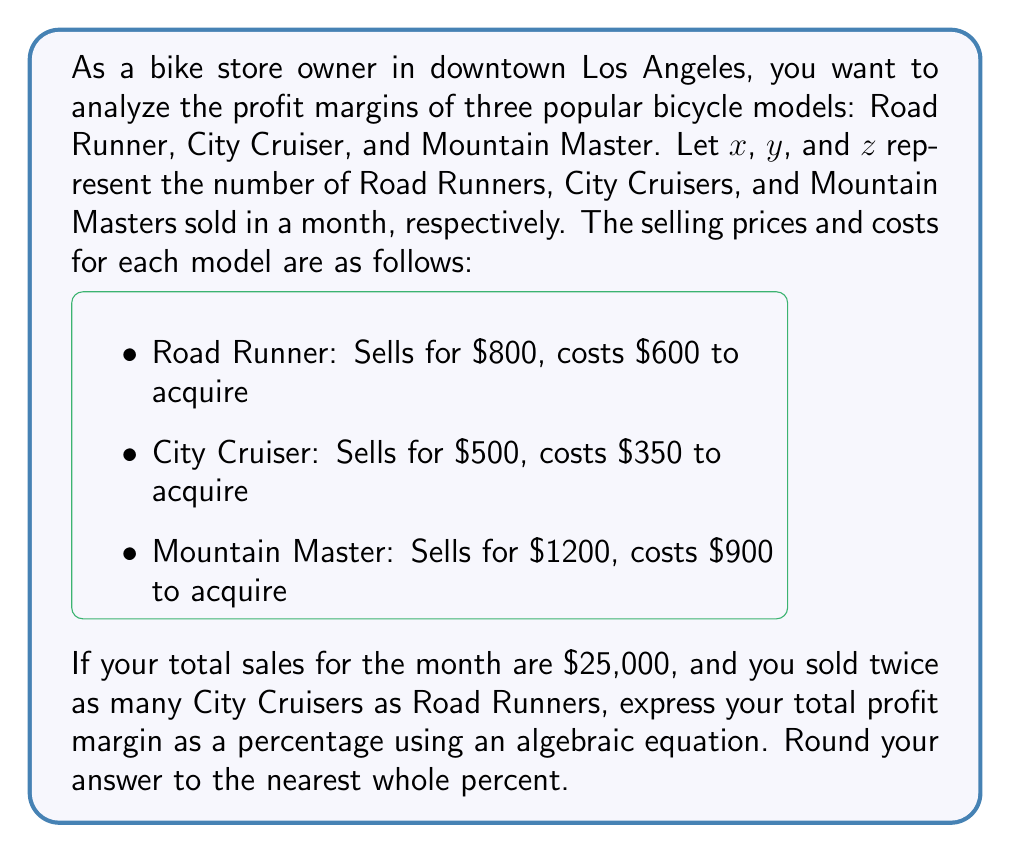Teach me how to tackle this problem. Let's approach this step-by-step:

1) First, let's define our variables:
   $x$ = number of Road Runners sold
   $y$ = number of City Cruisers sold
   $z$ = number of Mountain Masters sold

2) We're told that $y = 2x$, so we can substitute this in our equations.

3) The total sales equation:
   $800x + 500y + 1200z = 25000$
   Substituting $y = 2x$:
   $800x + 500(2x) + 1200z = 25000$
   $800x + 1000x + 1200z = 25000$
   $1800x + 1200z = 25000$ ... (Equation 1)

4) The total cost equation:
   $600x + 350y + 900z$
   Substituting $y = 2x$:
   $600x + 350(2x) + 900z$
   $600x + 700x + 900z$
   $1300x + 900z$ ... (Cost equation)

5) Profit = Sales - Cost
   $25000 - (1300x + 900z)$

6) To find $x$ and $z$, we need another equation. We can use the fact that $x$, $y$, and $z$ must be whole numbers that satisfy Equation 1.

7) Through trial and error or solving systems of equations, we find:
   $x = 10$, $y = 20$, $z = 5$

8) Now we can calculate the profit:
   Profit = $25000 - (1300(10) + 900(5))$
          = $25000 - (13000 + 4500)$
          = $25000 - 17500$
          = $7500$

9) Profit margin percentage = (Profit / Sales) * 100
   $\frac{7500}{25000} * 100 = 30\%$

Therefore, the profit margin is 30%.
Answer: 30% 